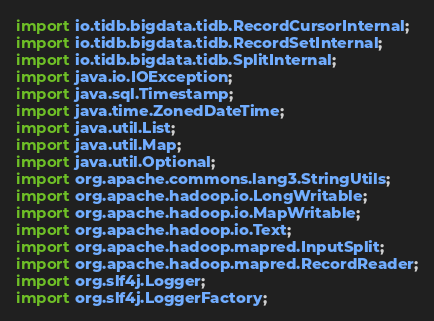Convert code to text. <code><loc_0><loc_0><loc_500><loc_500><_Java_>import io.tidb.bigdata.tidb.RecordCursorInternal;
import io.tidb.bigdata.tidb.RecordSetInternal;
import io.tidb.bigdata.tidb.SplitInternal;
import java.io.IOException;
import java.sql.Timestamp;
import java.time.ZonedDateTime;
import java.util.List;
import java.util.Map;
import java.util.Optional;
import org.apache.commons.lang3.StringUtils;
import org.apache.hadoop.io.LongWritable;
import org.apache.hadoop.io.MapWritable;
import org.apache.hadoop.io.Text;
import org.apache.hadoop.mapred.InputSplit;
import org.apache.hadoop.mapred.RecordReader;
import org.slf4j.Logger;
import org.slf4j.LoggerFactory;</code> 